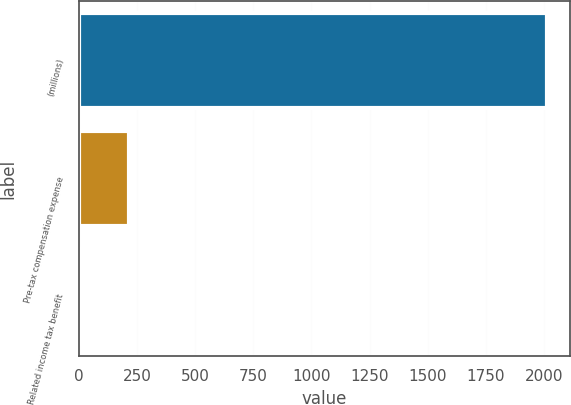Convert chart. <chart><loc_0><loc_0><loc_500><loc_500><bar_chart><fcel>(millions)<fcel>Pre-tax compensation expense<fcel>Related income tax benefit<nl><fcel>2013<fcel>213.9<fcel>14<nl></chart> 